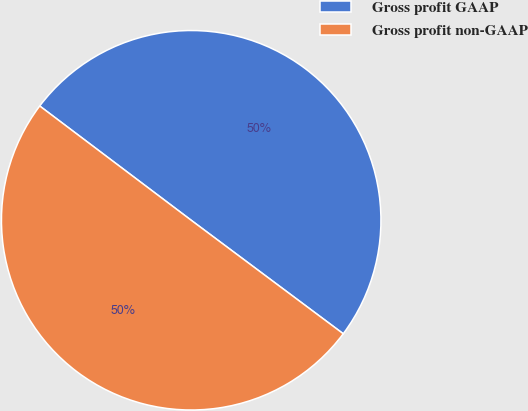<chart> <loc_0><loc_0><loc_500><loc_500><pie_chart><fcel>Gross profit GAAP<fcel>Gross profit non-GAAP<nl><fcel>49.92%<fcel>50.08%<nl></chart> 